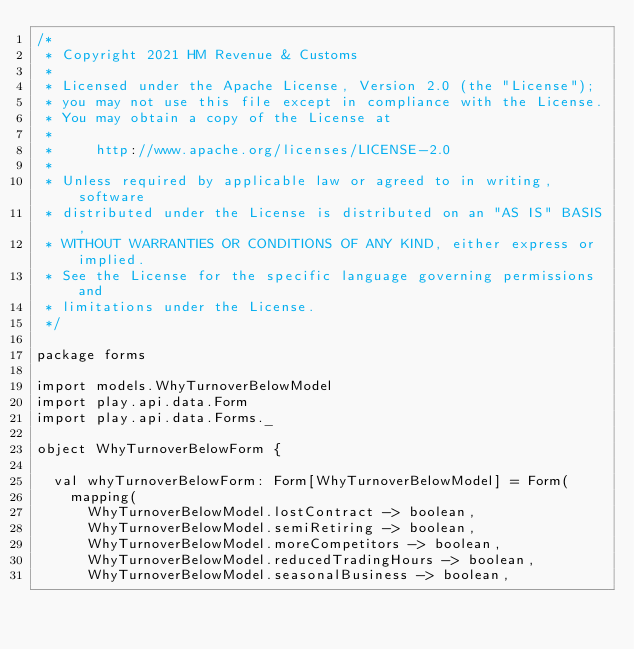Convert code to text. <code><loc_0><loc_0><loc_500><loc_500><_Scala_>/*
 * Copyright 2021 HM Revenue & Customs
 *
 * Licensed under the Apache License, Version 2.0 (the "License");
 * you may not use this file except in compliance with the License.
 * You may obtain a copy of the License at
 *
 *     http://www.apache.org/licenses/LICENSE-2.0
 *
 * Unless required by applicable law or agreed to in writing, software
 * distributed under the License is distributed on an "AS IS" BASIS,
 * WITHOUT WARRANTIES OR CONDITIONS OF ANY KIND, either express or implied.
 * See the License for the specific language governing permissions and
 * limitations under the License.
 */

package forms

import models.WhyTurnoverBelowModel
import play.api.data.Form
import play.api.data.Forms._

object WhyTurnoverBelowForm {

  val whyTurnoverBelowForm: Form[WhyTurnoverBelowModel] = Form(
    mapping(
      WhyTurnoverBelowModel.lostContract -> boolean,
      WhyTurnoverBelowModel.semiRetiring -> boolean,
      WhyTurnoverBelowModel.moreCompetitors -> boolean,
      WhyTurnoverBelowModel.reducedTradingHours -> boolean,
      WhyTurnoverBelowModel.seasonalBusiness -> boolean,</code> 